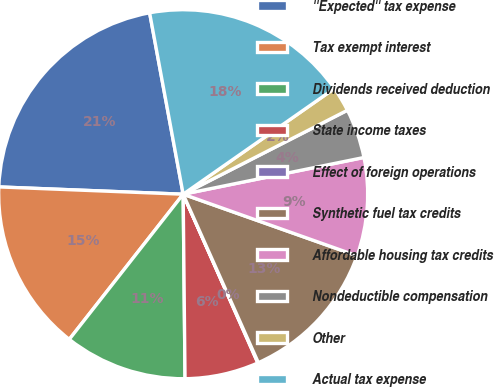Convert chart. <chart><loc_0><loc_0><loc_500><loc_500><pie_chart><fcel>''Expected'' tax expense<fcel>Tax exempt interest<fcel>Dividends received deduction<fcel>State income taxes<fcel>Effect of foreign operations<fcel>Synthetic fuel tax credits<fcel>Affordable housing tax credits<fcel>Nondeductible compensation<fcel>Other<fcel>Actual tax expense<nl><fcel>21.46%<fcel>15.04%<fcel>10.75%<fcel>6.47%<fcel>0.05%<fcel>12.9%<fcel>8.61%<fcel>4.33%<fcel>2.19%<fcel>18.2%<nl></chart> 